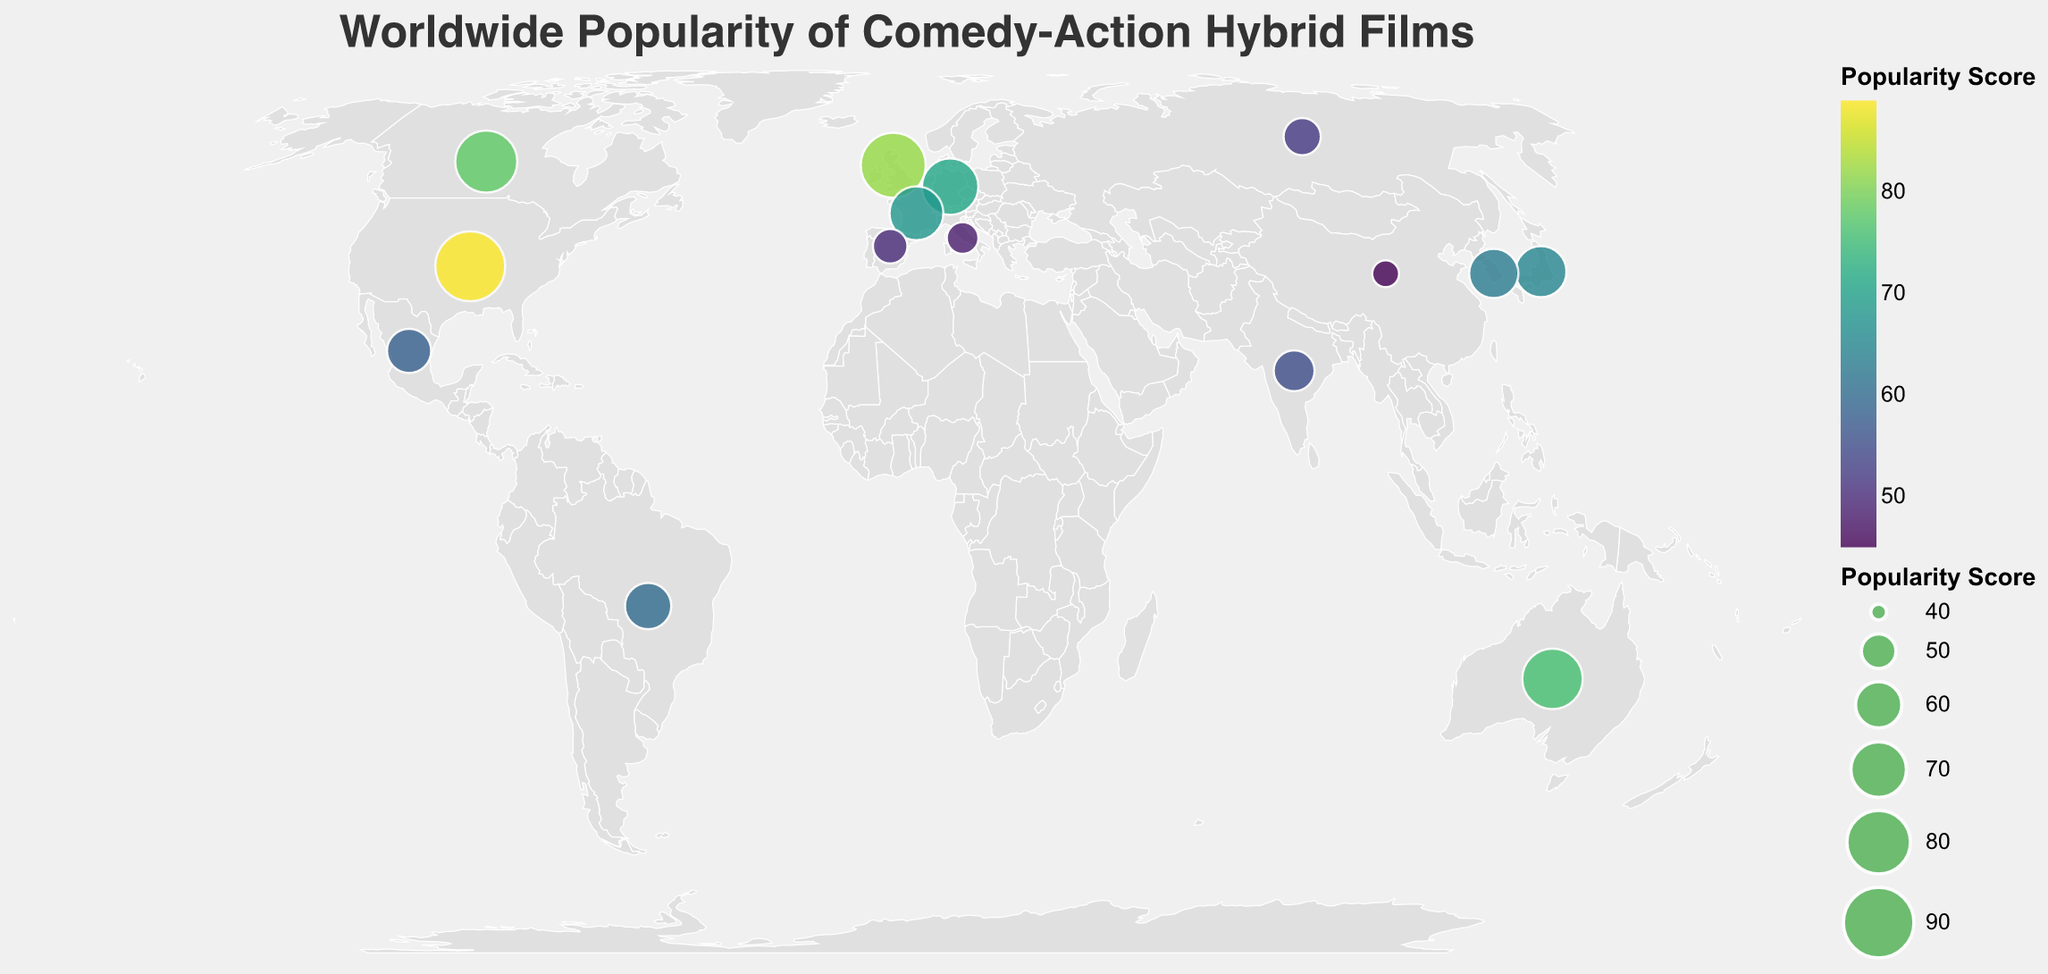Which region has the highest popularity score? The data shows the popularity scores of different regions. The United States has the highest score of 89, clearly indicated by the largest and potentially the darkest colored circle on the plot.
Answer: United States Which region has the lowest popularity score? The data indicates that China has the lowest popularity score of 45, visible by the smallest and potentially lightest colored circle on the plot.
Answer: China What is the popularity score difference between Japan and South Korea? Japan has a popularity score of 65 and South Korea has a score of 63. The difference is calculated as 65 - 63.
Answer: 2 How many regions have a popularity score higher than 70? The regions with scores higher than 70 are the United States (89), United Kingdom (82), Canada (78), and Australia (76). Thus, there are 4 regions.
Answer: 4 Which region in Europe has the highest popularity score? Among European regions, the United Kingdom has the highest popularity score of 82.
Answer: United Kingdom What is the average popularity score of the regions in the Americas? The regions in the Americas are the United States, Canada, Brazil, and Mexico. The scores are 89, 78, 60, and 58. The average is (89 + 78 + 60 + 58) / 4.
Answer: 71.25 How does the popularity score of France compare to that of Germany? France has a popularity score of 68 and Germany has 71. Germany's score is higher than France's by 3 points.
Answer: France is 3 points lower What is the sum of popularity scores for regions in Asia? The regions in Asia are Japan (65), South Korea (63), India (55), Russia (52), and China (45). The sum is calculated as 65 + 63 + 55 + 52 + 45.
Answer: 280 Which region is more popular, Australia or Brazil? Australia has a popularity score of 76, while Brazil has 60. Australia is more popular.
Answer: Australia What is the median popularity score of all regions? To find the median, list all scores in ascending order: 45, 48, 50, 52, 55, 58, 60, 63, 65, 68, 71, 76, 78, 82, 89. The middle score (8th in the list) is 63.
Answer: 63 